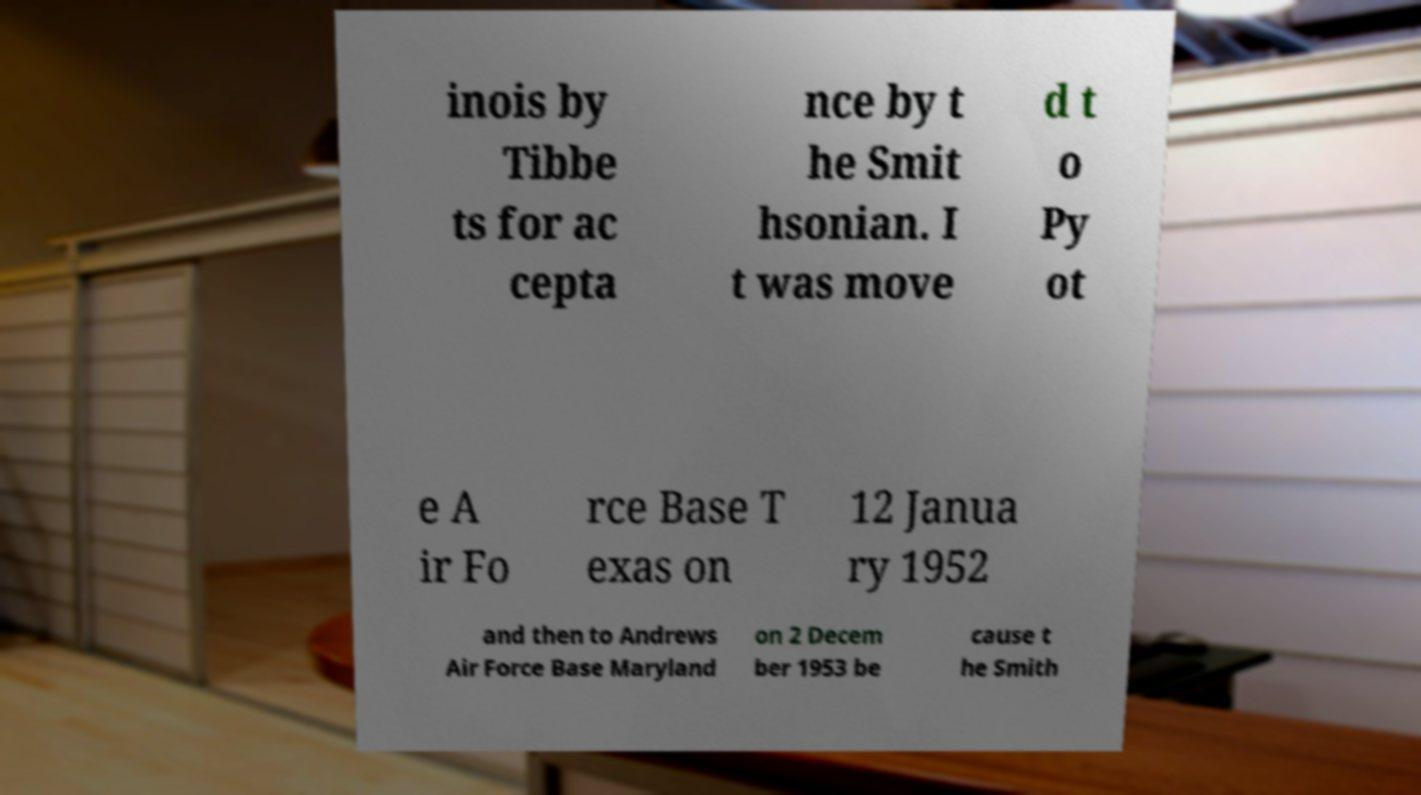Can you read and provide the text displayed in the image?This photo seems to have some interesting text. Can you extract and type it out for me? inois by Tibbe ts for ac cepta nce by t he Smit hsonian. I t was move d t o Py ot e A ir Fo rce Base T exas on 12 Janua ry 1952 and then to Andrews Air Force Base Maryland on 2 Decem ber 1953 be cause t he Smith 